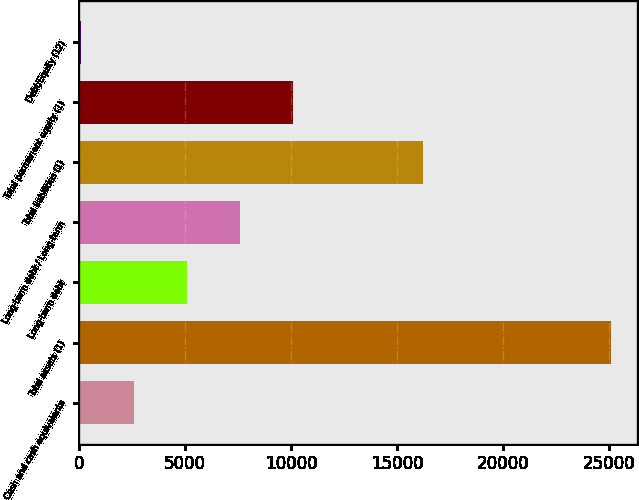Convert chart. <chart><loc_0><loc_0><loc_500><loc_500><bar_chart><fcel>Cash and cash equivalents<fcel>Total assets (1)<fcel>Long-term debt<fcel>Long-term debt / Long-term<fcel>Total liabilities (1)<fcel>Total permanent equity (1)<fcel>Debt/Equity (12)<nl><fcel>2585.08<fcel>25073.2<fcel>5083.76<fcel>7582.44<fcel>16210.2<fcel>10081.1<fcel>86.4<nl></chart> 